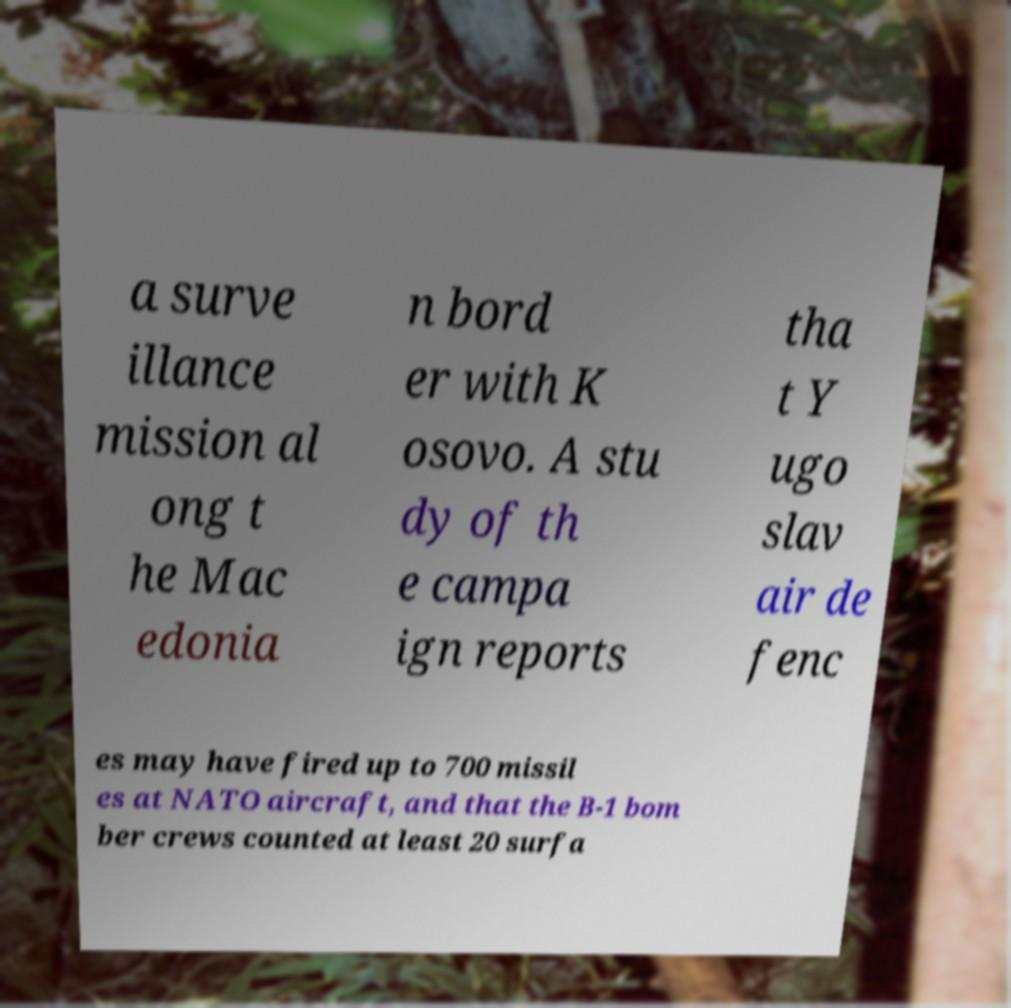I need the written content from this picture converted into text. Can you do that? a surve illance mission al ong t he Mac edonia n bord er with K osovo. A stu dy of th e campa ign reports tha t Y ugo slav air de fenc es may have fired up to 700 missil es at NATO aircraft, and that the B-1 bom ber crews counted at least 20 surfa 